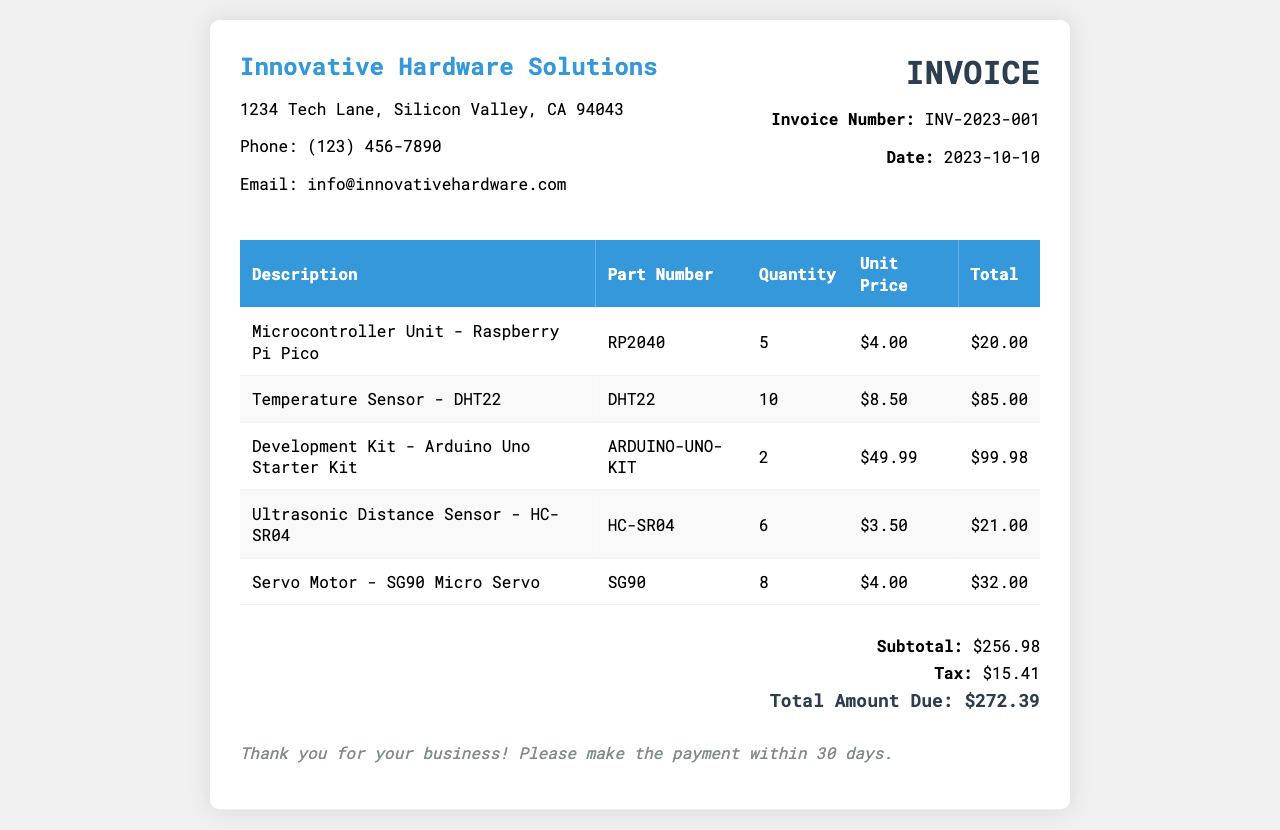What is the invoice number? The invoice number is a unique identifier for the invoice, which is listed in the document.
Answer: INV-2023-001 What is the total amount due? The total amount due is the final charge indicated in the document after tax has been applied.
Answer: $272.39 How many temperature sensors were purchased? The quantity of temperature sensors can be found in the itemized list of purchases.
Answer: 10 What is the part number for the microcontroller unit? The part number is provided alongside each item description in the document.
Answer: RP2040 What is the subtotal before tax? The subtotal is the sum of all item totals before tax is added, clearly listed in the summary section.
Answer: $256.98 What is the unit price of the ultrasonic distance sensor? The unit price is the cost for each ultrasonic distance sensor as shown in the table.
Answer: $3.50 What is the quantity of development kits ordered? The quantity for each type of development kit is specified in the itemized invoice.
Answer: 2 What company issued the invoice? The company name is prominently displayed at the top of the invoice.
Answer: Innovative Hardware Solutions What tax amount is applied to the invoice? The tax amount is listed in the summary section of the invoice.
Answer: $15.41 